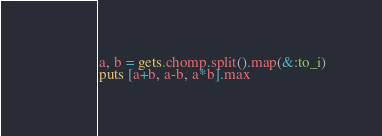<code> <loc_0><loc_0><loc_500><loc_500><_Ruby_>a, b = gets.chomp.split().map(&:to_i)
puts [a+b, a-b, a*b].max
</code> 